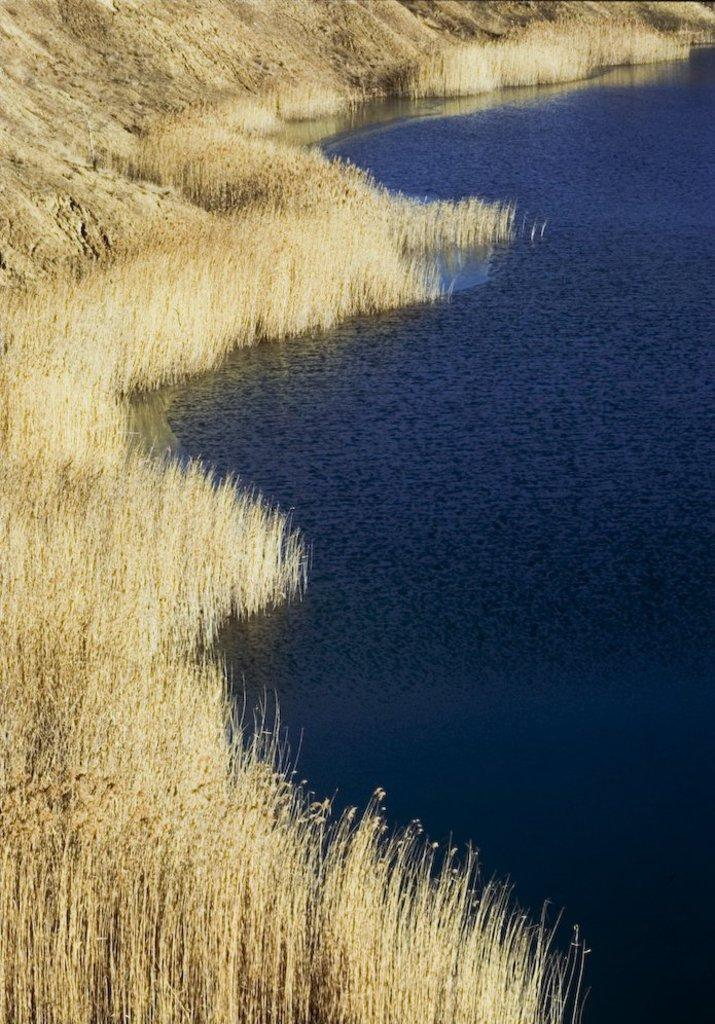What type of natural feature is on the right side of the image? There is a river on the right side of the image. What type of vegetation is on the left side of the image? There is grass on the left side of the image. Where is the bomb located in the image? There is no bomb present in the image. Can you describe the relationship between the grass and the river in the image? The grass and the river are separate features in the image, with the grass on the left side and the river on the right side. There is no direct relationship between them in the image. 